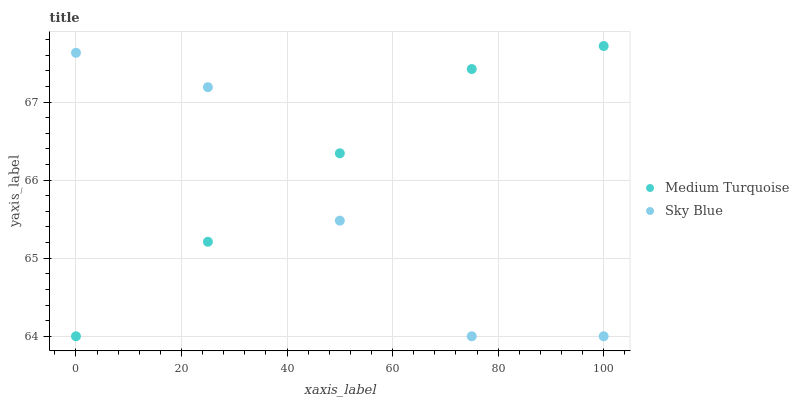Does Sky Blue have the minimum area under the curve?
Answer yes or no. Yes. Does Medium Turquoise have the maximum area under the curve?
Answer yes or no. Yes. Does Medium Turquoise have the minimum area under the curve?
Answer yes or no. No. Is Medium Turquoise the smoothest?
Answer yes or no. Yes. Is Sky Blue the roughest?
Answer yes or no. Yes. Is Medium Turquoise the roughest?
Answer yes or no. No. Does Sky Blue have the lowest value?
Answer yes or no. Yes. Does Medium Turquoise have the highest value?
Answer yes or no. Yes. Does Medium Turquoise intersect Sky Blue?
Answer yes or no. Yes. Is Medium Turquoise less than Sky Blue?
Answer yes or no. No. Is Medium Turquoise greater than Sky Blue?
Answer yes or no. No. 